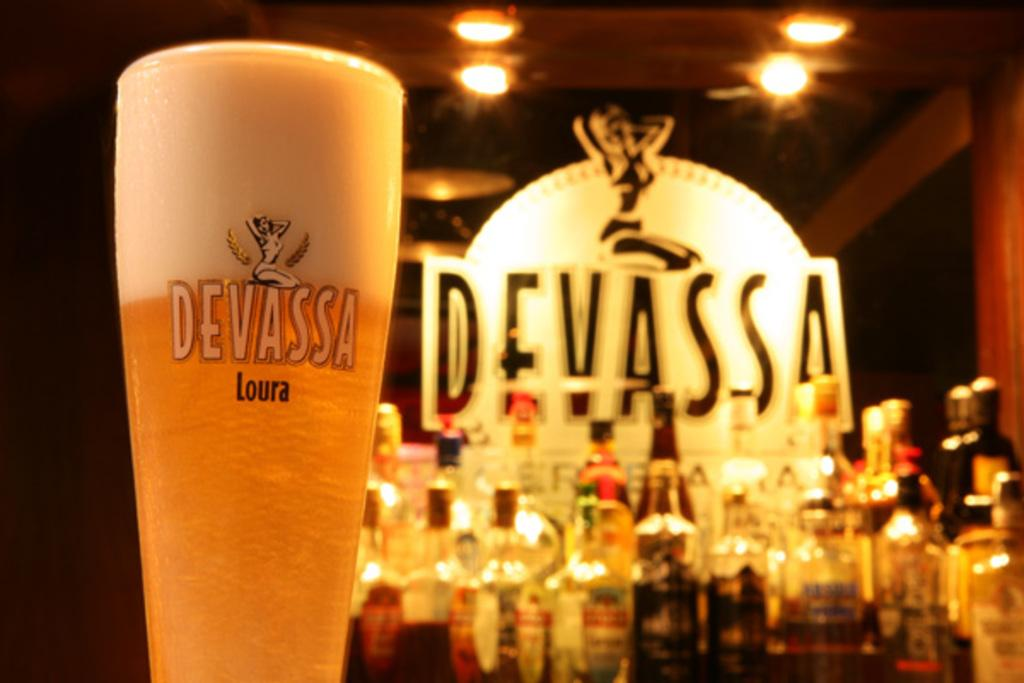<image>
Offer a succinct explanation of the picture presented. Cup of Devassa Loura beer in front of a sign that says Devassa. 